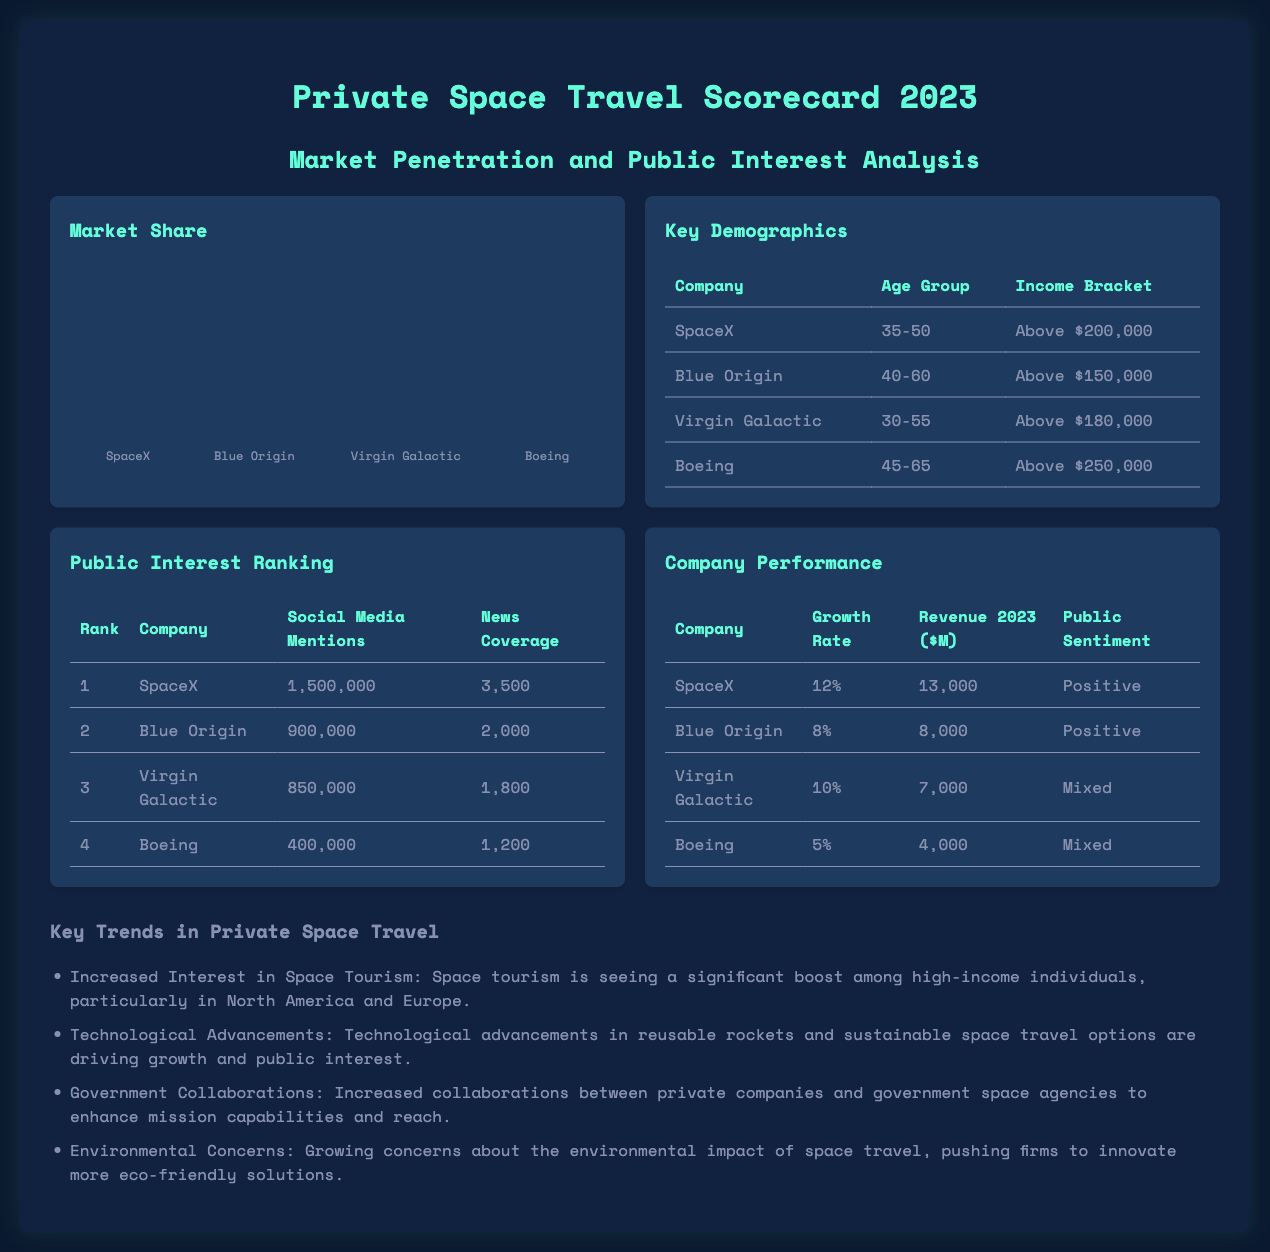What is the market share percentage for SpaceX? The market share percentage for SpaceX is directly provided in the document as 45%.
Answer: 45% Which company has the highest social media mentions? The document lists social media mentions for each company, where SpaceX has the highest at 1,500,000 mentions.
Answer: SpaceX What is the income bracket for Virgin Galactic customers? The document specifies that Virgin Galactic customers fall in the income bracket above $180,000.
Answer: Above $180,000 What is the public sentiment for Boeing? The document categorizes Boeing's public sentiment as mixed.
Answer: Mixed Which age group does Blue Origin target? According to the table in the document, Blue Origin targets the age group 40-60.
Answer: 40-60 What is the growth rate of SpaceX in 2023? The growth rate for SpaceX is given as 12% in the document.
Answer: 12% How many news coverage articles are associated with Virgin Galactic? The document states that Virgin Galactic has 1,800 news coverage articles.
Answer: 1,800 What is the trend related to environmental concerns? The document notes that there are growing concerns about the environmental impact of space travel, prompting firms to innovate eco-friendly solutions.
Answer: Environmental impact concerns Which company has a revenue of $8,000 million in 2023? The document indicates that Blue Origin has a revenue of $8,000 million in 2023.
Answer: Blue Origin 